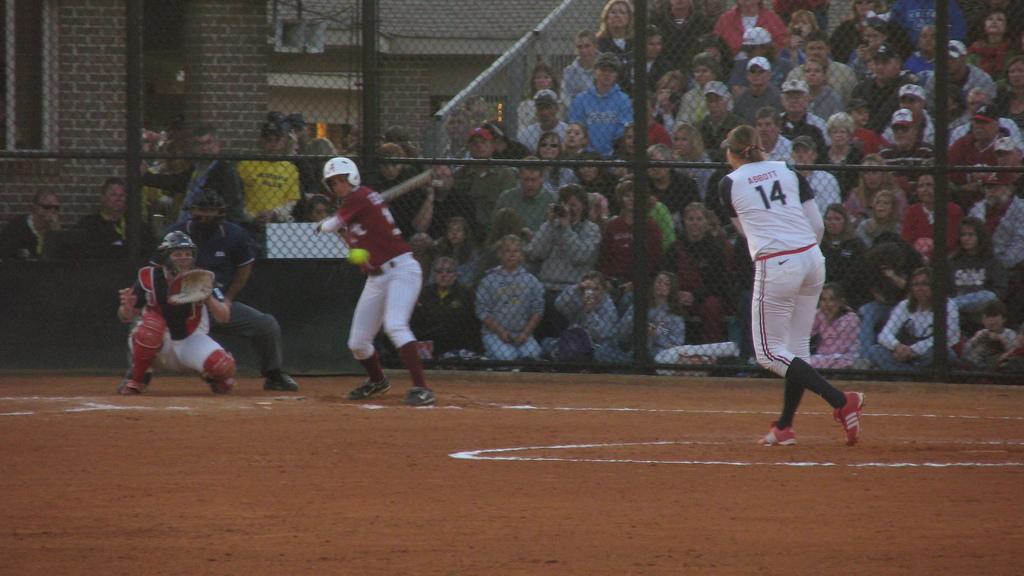What is the pitcher's number?
Make the answer very short. 14. 